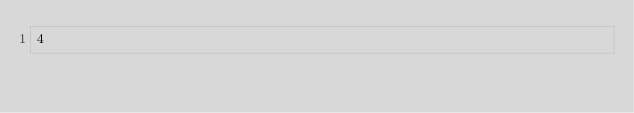<code> <loc_0><loc_0><loc_500><loc_500><_Clojure_>4</code> 